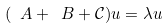Convert formula to latex. <formula><loc_0><loc_0><loc_500><loc_500>( \ A + \ B + \mathcal { C } ) u = \lambda u</formula> 